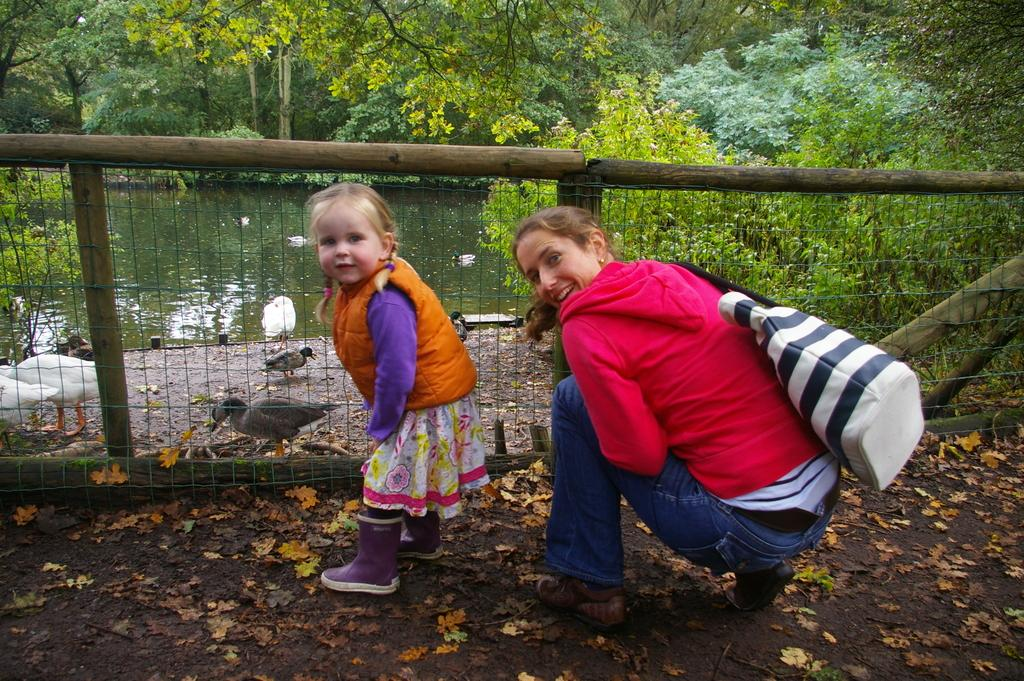Who is present in the image? There is a girl in the image. What is the lady wearing in the image? The lady is wearing a bag in the image. What can be seen in the background of the image? There is fencing with wooden poles, leaves on the ground, water, birds, and trees in the background. What type of rail can be seen in the image? There is no rail present in the image. What experience does the girl have with the birds in the image? The image does not provide any information about the girl's experience with the birds; it only shows that there are birds in the background. 